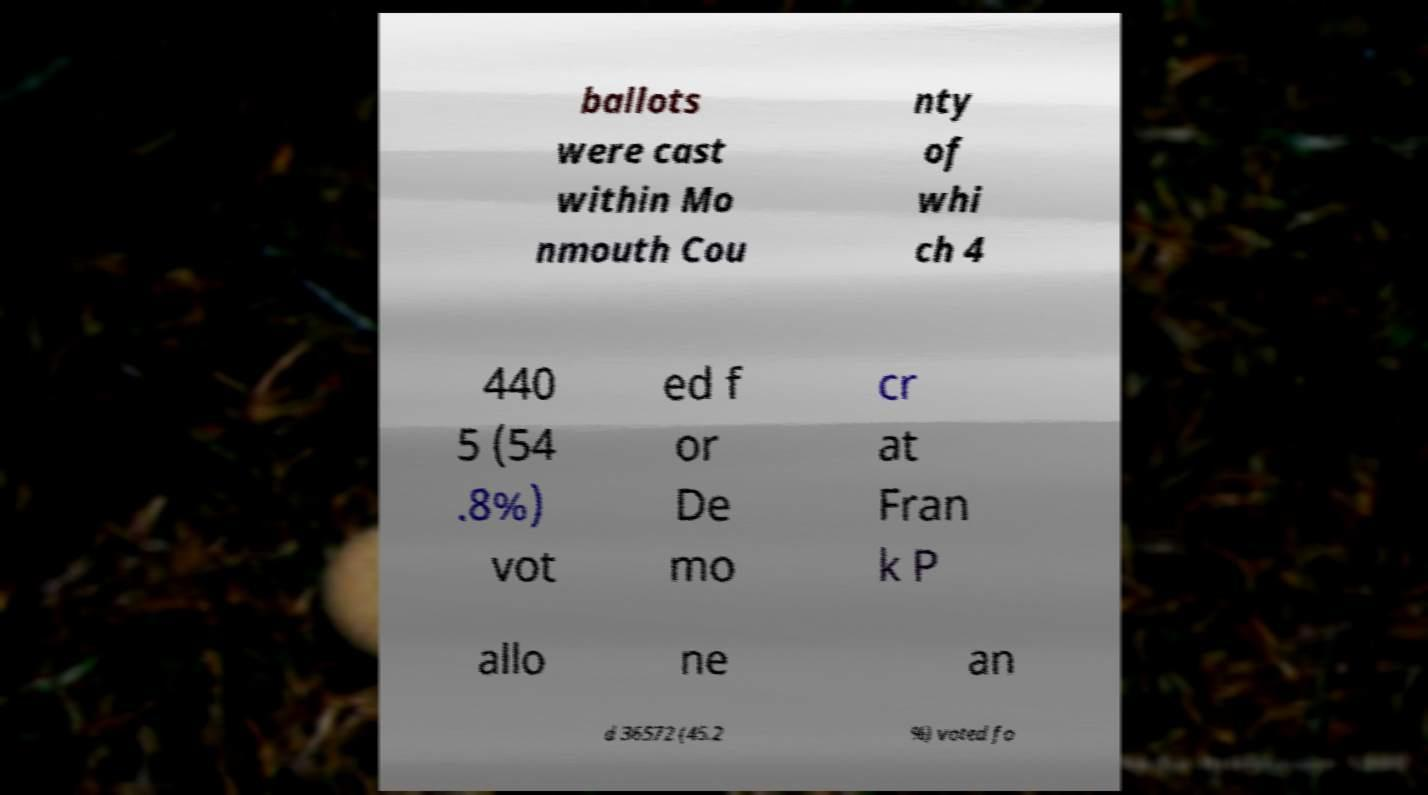There's text embedded in this image that I need extracted. Can you transcribe it verbatim? ballots were cast within Mo nmouth Cou nty of whi ch 4 440 5 (54 .8%) vot ed f or De mo cr at Fran k P allo ne an d 36572 (45.2 %) voted fo 